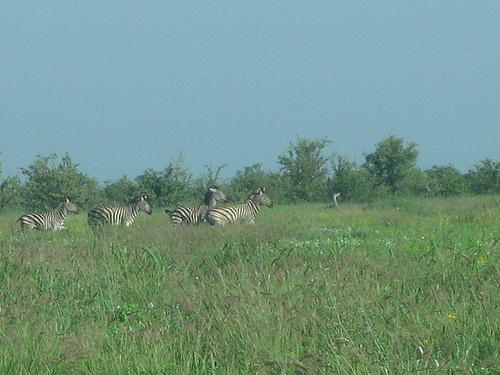Describe the objects in this image and their specific colors. I can see zebra in lightblue, gray, and darkgray tones, zebra in lightblue, gray, and darkgray tones, zebra in lightblue, gray, and darkgray tones, and zebra in lightblue, gray, darkgray, black, and purple tones in this image. 